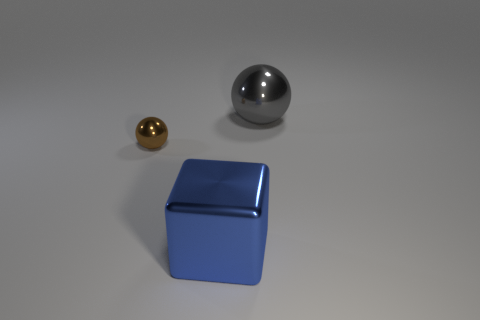Subtract all brown spheres. How many spheres are left? 1 Add 2 small brown shiny balls. How many objects exist? 5 Subtract all cubes. How many objects are left? 2 Subtract all large cylinders. Subtract all gray shiny balls. How many objects are left? 2 Add 3 big metallic spheres. How many big metallic spheres are left? 4 Add 2 small metallic objects. How many small metallic objects exist? 3 Subtract 1 gray balls. How many objects are left? 2 